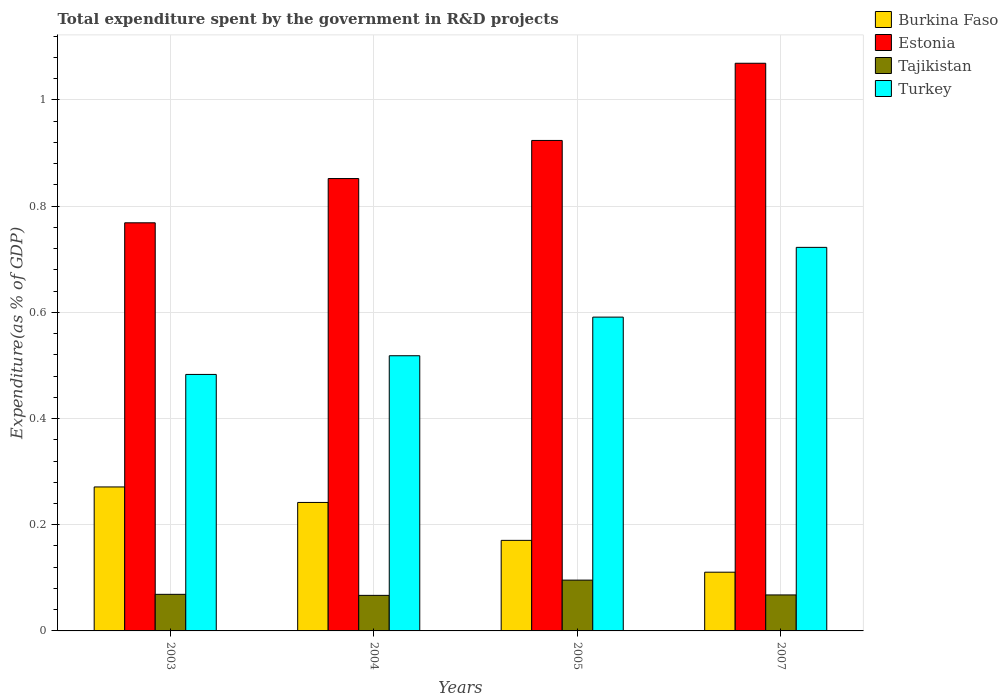How many different coloured bars are there?
Your answer should be very brief. 4. How many groups of bars are there?
Keep it short and to the point. 4. Are the number of bars per tick equal to the number of legend labels?
Provide a succinct answer. Yes. Are the number of bars on each tick of the X-axis equal?
Provide a succinct answer. Yes. How many bars are there on the 2nd tick from the right?
Offer a very short reply. 4. What is the total expenditure spent by the government in R&D projects in Tajikistan in 2003?
Give a very brief answer. 0.07. Across all years, what is the maximum total expenditure spent by the government in R&D projects in Turkey?
Your response must be concise. 0.72. Across all years, what is the minimum total expenditure spent by the government in R&D projects in Estonia?
Offer a terse response. 0.77. In which year was the total expenditure spent by the government in R&D projects in Tajikistan maximum?
Provide a succinct answer. 2005. What is the total total expenditure spent by the government in R&D projects in Estonia in the graph?
Keep it short and to the point. 3.61. What is the difference between the total expenditure spent by the government in R&D projects in Tajikistan in 2005 and that in 2007?
Provide a succinct answer. 0.03. What is the difference between the total expenditure spent by the government in R&D projects in Turkey in 2007 and the total expenditure spent by the government in R&D projects in Burkina Faso in 2004?
Provide a succinct answer. 0.48. What is the average total expenditure spent by the government in R&D projects in Tajikistan per year?
Give a very brief answer. 0.07. In the year 2005, what is the difference between the total expenditure spent by the government in R&D projects in Burkina Faso and total expenditure spent by the government in R&D projects in Estonia?
Provide a short and direct response. -0.75. What is the ratio of the total expenditure spent by the government in R&D projects in Tajikistan in 2005 to that in 2007?
Your answer should be very brief. 1.41. Is the total expenditure spent by the government in R&D projects in Turkey in 2003 less than that in 2007?
Make the answer very short. Yes. Is the difference between the total expenditure spent by the government in R&D projects in Burkina Faso in 2004 and 2005 greater than the difference between the total expenditure spent by the government in R&D projects in Estonia in 2004 and 2005?
Keep it short and to the point. Yes. What is the difference between the highest and the second highest total expenditure spent by the government in R&D projects in Estonia?
Your answer should be very brief. 0.15. What is the difference between the highest and the lowest total expenditure spent by the government in R&D projects in Estonia?
Your answer should be compact. 0.3. In how many years, is the total expenditure spent by the government in R&D projects in Tajikistan greater than the average total expenditure spent by the government in R&D projects in Tajikistan taken over all years?
Provide a short and direct response. 1. Is the sum of the total expenditure spent by the government in R&D projects in Burkina Faso in 2003 and 2007 greater than the maximum total expenditure spent by the government in R&D projects in Turkey across all years?
Your response must be concise. No. What does the 1st bar from the left in 2004 represents?
Give a very brief answer. Burkina Faso. What does the 4th bar from the right in 2004 represents?
Provide a short and direct response. Burkina Faso. Is it the case that in every year, the sum of the total expenditure spent by the government in R&D projects in Tajikistan and total expenditure spent by the government in R&D projects in Turkey is greater than the total expenditure spent by the government in R&D projects in Estonia?
Your answer should be compact. No. Are all the bars in the graph horizontal?
Provide a succinct answer. No. How many years are there in the graph?
Provide a succinct answer. 4. Does the graph contain any zero values?
Keep it short and to the point. No. What is the title of the graph?
Your answer should be very brief. Total expenditure spent by the government in R&D projects. Does "El Salvador" appear as one of the legend labels in the graph?
Offer a very short reply. No. What is the label or title of the X-axis?
Give a very brief answer. Years. What is the label or title of the Y-axis?
Provide a short and direct response. Expenditure(as % of GDP). What is the Expenditure(as % of GDP) of Burkina Faso in 2003?
Provide a short and direct response. 0.27. What is the Expenditure(as % of GDP) of Estonia in 2003?
Ensure brevity in your answer.  0.77. What is the Expenditure(as % of GDP) of Tajikistan in 2003?
Provide a short and direct response. 0.07. What is the Expenditure(as % of GDP) of Turkey in 2003?
Give a very brief answer. 0.48. What is the Expenditure(as % of GDP) of Burkina Faso in 2004?
Your answer should be very brief. 0.24. What is the Expenditure(as % of GDP) of Estonia in 2004?
Ensure brevity in your answer.  0.85. What is the Expenditure(as % of GDP) in Tajikistan in 2004?
Keep it short and to the point. 0.07. What is the Expenditure(as % of GDP) of Turkey in 2004?
Your response must be concise. 0.52. What is the Expenditure(as % of GDP) in Burkina Faso in 2005?
Provide a short and direct response. 0.17. What is the Expenditure(as % of GDP) of Estonia in 2005?
Make the answer very short. 0.92. What is the Expenditure(as % of GDP) in Tajikistan in 2005?
Your answer should be very brief. 0.1. What is the Expenditure(as % of GDP) of Turkey in 2005?
Your answer should be compact. 0.59. What is the Expenditure(as % of GDP) of Burkina Faso in 2007?
Your answer should be compact. 0.11. What is the Expenditure(as % of GDP) of Estonia in 2007?
Offer a terse response. 1.07. What is the Expenditure(as % of GDP) in Tajikistan in 2007?
Your answer should be very brief. 0.07. What is the Expenditure(as % of GDP) of Turkey in 2007?
Keep it short and to the point. 0.72. Across all years, what is the maximum Expenditure(as % of GDP) of Burkina Faso?
Offer a terse response. 0.27. Across all years, what is the maximum Expenditure(as % of GDP) in Estonia?
Ensure brevity in your answer.  1.07. Across all years, what is the maximum Expenditure(as % of GDP) in Tajikistan?
Offer a terse response. 0.1. Across all years, what is the maximum Expenditure(as % of GDP) in Turkey?
Offer a very short reply. 0.72. Across all years, what is the minimum Expenditure(as % of GDP) of Burkina Faso?
Ensure brevity in your answer.  0.11. Across all years, what is the minimum Expenditure(as % of GDP) in Estonia?
Your answer should be compact. 0.77. Across all years, what is the minimum Expenditure(as % of GDP) in Tajikistan?
Provide a succinct answer. 0.07. Across all years, what is the minimum Expenditure(as % of GDP) of Turkey?
Offer a very short reply. 0.48. What is the total Expenditure(as % of GDP) in Burkina Faso in the graph?
Keep it short and to the point. 0.79. What is the total Expenditure(as % of GDP) in Estonia in the graph?
Keep it short and to the point. 3.61. What is the total Expenditure(as % of GDP) in Tajikistan in the graph?
Ensure brevity in your answer.  0.3. What is the total Expenditure(as % of GDP) in Turkey in the graph?
Your response must be concise. 2.31. What is the difference between the Expenditure(as % of GDP) in Burkina Faso in 2003 and that in 2004?
Make the answer very short. 0.03. What is the difference between the Expenditure(as % of GDP) in Estonia in 2003 and that in 2004?
Keep it short and to the point. -0.08. What is the difference between the Expenditure(as % of GDP) of Tajikistan in 2003 and that in 2004?
Offer a terse response. 0. What is the difference between the Expenditure(as % of GDP) in Turkey in 2003 and that in 2004?
Your response must be concise. -0.04. What is the difference between the Expenditure(as % of GDP) in Burkina Faso in 2003 and that in 2005?
Your response must be concise. 0.1. What is the difference between the Expenditure(as % of GDP) of Estonia in 2003 and that in 2005?
Provide a succinct answer. -0.16. What is the difference between the Expenditure(as % of GDP) of Tajikistan in 2003 and that in 2005?
Provide a succinct answer. -0.03. What is the difference between the Expenditure(as % of GDP) of Turkey in 2003 and that in 2005?
Make the answer very short. -0.11. What is the difference between the Expenditure(as % of GDP) in Burkina Faso in 2003 and that in 2007?
Your answer should be compact. 0.16. What is the difference between the Expenditure(as % of GDP) in Estonia in 2003 and that in 2007?
Your response must be concise. -0.3. What is the difference between the Expenditure(as % of GDP) of Tajikistan in 2003 and that in 2007?
Offer a terse response. 0. What is the difference between the Expenditure(as % of GDP) in Turkey in 2003 and that in 2007?
Your answer should be compact. -0.24. What is the difference between the Expenditure(as % of GDP) of Burkina Faso in 2004 and that in 2005?
Offer a terse response. 0.07. What is the difference between the Expenditure(as % of GDP) in Estonia in 2004 and that in 2005?
Make the answer very short. -0.07. What is the difference between the Expenditure(as % of GDP) in Tajikistan in 2004 and that in 2005?
Offer a very short reply. -0.03. What is the difference between the Expenditure(as % of GDP) of Turkey in 2004 and that in 2005?
Make the answer very short. -0.07. What is the difference between the Expenditure(as % of GDP) in Burkina Faso in 2004 and that in 2007?
Keep it short and to the point. 0.13. What is the difference between the Expenditure(as % of GDP) in Estonia in 2004 and that in 2007?
Provide a succinct answer. -0.22. What is the difference between the Expenditure(as % of GDP) of Tajikistan in 2004 and that in 2007?
Make the answer very short. -0. What is the difference between the Expenditure(as % of GDP) in Turkey in 2004 and that in 2007?
Ensure brevity in your answer.  -0.2. What is the difference between the Expenditure(as % of GDP) in Estonia in 2005 and that in 2007?
Offer a very short reply. -0.15. What is the difference between the Expenditure(as % of GDP) of Tajikistan in 2005 and that in 2007?
Ensure brevity in your answer.  0.03. What is the difference between the Expenditure(as % of GDP) of Turkey in 2005 and that in 2007?
Make the answer very short. -0.13. What is the difference between the Expenditure(as % of GDP) of Burkina Faso in 2003 and the Expenditure(as % of GDP) of Estonia in 2004?
Your answer should be very brief. -0.58. What is the difference between the Expenditure(as % of GDP) of Burkina Faso in 2003 and the Expenditure(as % of GDP) of Tajikistan in 2004?
Offer a very short reply. 0.2. What is the difference between the Expenditure(as % of GDP) of Burkina Faso in 2003 and the Expenditure(as % of GDP) of Turkey in 2004?
Offer a very short reply. -0.25. What is the difference between the Expenditure(as % of GDP) of Estonia in 2003 and the Expenditure(as % of GDP) of Tajikistan in 2004?
Ensure brevity in your answer.  0.7. What is the difference between the Expenditure(as % of GDP) in Estonia in 2003 and the Expenditure(as % of GDP) in Turkey in 2004?
Provide a short and direct response. 0.25. What is the difference between the Expenditure(as % of GDP) in Tajikistan in 2003 and the Expenditure(as % of GDP) in Turkey in 2004?
Offer a terse response. -0.45. What is the difference between the Expenditure(as % of GDP) of Burkina Faso in 2003 and the Expenditure(as % of GDP) of Estonia in 2005?
Give a very brief answer. -0.65. What is the difference between the Expenditure(as % of GDP) in Burkina Faso in 2003 and the Expenditure(as % of GDP) in Tajikistan in 2005?
Provide a short and direct response. 0.18. What is the difference between the Expenditure(as % of GDP) in Burkina Faso in 2003 and the Expenditure(as % of GDP) in Turkey in 2005?
Make the answer very short. -0.32. What is the difference between the Expenditure(as % of GDP) in Estonia in 2003 and the Expenditure(as % of GDP) in Tajikistan in 2005?
Make the answer very short. 0.67. What is the difference between the Expenditure(as % of GDP) in Estonia in 2003 and the Expenditure(as % of GDP) in Turkey in 2005?
Your answer should be very brief. 0.18. What is the difference between the Expenditure(as % of GDP) in Tajikistan in 2003 and the Expenditure(as % of GDP) in Turkey in 2005?
Your answer should be very brief. -0.52. What is the difference between the Expenditure(as % of GDP) of Burkina Faso in 2003 and the Expenditure(as % of GDP) of Estonia in 2007?
Ensure brevity in your answer.  -0.8. What is the difference between the Expenditure(as % of GDP) in Burkina Faso in 2003 and the Expenditure(as % of GDP) in Tajikistan in 2007?
Keep it short and to the point. 0.2. What is the difference between the Expenditure(as % of GDP) of Burkina Faso in 2003 and the Expenditure(as % of GDP) of Turkey in 2007?
Make the answer very short. -0.45. What is the difference between the Expenditure(as % of GDP) of Estonia in 2003 and the Expenditure(as % of GDP) of Tajikistan in 2007?
Your response must be concise. 0.7. What is the difference between the Expenditure(as % of GDP) of Estonia in 2003 and the Expenditure(as % of GDP) of Turkey in 2007?
Your response must be concise. 0.05. What is the difference between the Expenditure(as % of GDP) of Tajikistan in 2003 and the Expenditure(as % of GDP) of Turkey in 2007?
Offer a very short reply. -0.65. What is the difference between the Expenditure(as % of GDP) in Burkina Faso in 2004 and the Expenditure(as % of GDP) in Estonia in 2005?
Offer a very short reply. -0.68. What is the difference between the Expenditure(as % of GDP) of Burkina Faso in 2004 and the Expenditure(as % of GDP) of Tajikistan in 2005?
Provide a short and direct response. 0.15. What is the difference between the Expenditure(as % of GDP) of Burkina Faso in 2004 and the Expenditure(as % of GDP) of Turkey in 2005?
Offer a very short reply. -0.35. What is the difference between the Expenditure(as % of GDP) in Estonia in 2004 and the Expenditure(as % of GDP) in Tajikistan in 2005?
Provide a short and direct response. 0.76. What is the difference between the Expenditure(as % of GDP) of Estonia in 2004 and the Expenditure(as % of GDP) of Turkey in 2005?
Offer a very short reply. 0.26. What is the difference between the Expenditure(as % of GDP) in Tajikistan in 2004 and the Expenditure(as % of GDP) in Turkey in 2005?
Offer a very short reply. -0.52. What is the difference between the Expenditure(as % of GDP) in Burkina Faso in 2004 and the Expenditure(as % of GDP) in Estonia in 2007?
Keep it short and to the point. -0.83. What is the difference between the Expenditure(as % of GDP) in Burkina Faso in 2004 and the Expenditure(as % of GDP) in Tajikistan in 2007?
Your answer should be compact. 0.17. What is the difference between the Expenditure(as % of GDP) in Burkina Faso in 2004 and the Expenditure(as % of GDP) in Turkey in 2007?
Ensure brevity in your answer.  -0.48. What is the difference between the Expenditure(as % of GDP) in Estonia in 2004 and the Expenditure(as % of GDP) in Tajikistan in 2007?
Your answer should be compact. 0.78. What is the difference between the Expenditure(as % of GDP) in Estonia in 2004 and the Expenditure(as % of GDP) in Turkey in 2007?
Give a very brief answer. 0.13. What is the difference between the Expenditure(as % of GDP) of Tajikistan in 2004 and the Expenditure(as % of GDP) of Turkey in 2007?
Your answer should be compact. -0.66. What is the difference between the Expenditure(as % of GDP) in Burkina Faso in 2005 and the Expenditure(as % of GDP) in Estonia in 2007?
Your response must be concise. -0.9. What is the difference between the Expenditure(as % of GDP) of Burkina Faso in 2005 and the Expenditure(as % of GDP) of Tajikistan in 2007?
Offer a terse response. 0.1. What is the difference between the Expenditure(as % of GDP) in Burkina Faso in 2005 and the Expenditure(as % of GDP) in Turkey in 2007?
Provide a short and direct response. -0.55. What is the difference between the Expenditure(as % of GDP) of Estonia in 2005 and the Expenditure(as % of GDP) of Tajikistan in 2007?
Your answer should be very brief. 0.86. What is the difference between the Expenditure(as % of GDP) of Estonia in 2005 and the Expenditure(as % of GDP) of Turkey in 2007?
Provide a short and direct response. 0.2. What is the difference between the Expenditure(as % of GDP) in Tajikistan in 2005 and the Expenditure(as % of GDP) in Turkey in 2007?
Your answer should be very brief. -0.63. What is the average Expenditure(as % of GDP) of Burkina Faso per year?
Keep it short and to the point. 0.2. What is the average Expenditure(as % of GDP) in Estonia per year?
Keep it short and to the point. 0.9. What is the average Expenditure(as % of GDP) in Tajikistan per year?
Keep it short and to the point. 0.07. What is the average Expenditure(as % of GDP) of Turkey per year?
Provide a succinct answer. 0.58. In the year 2003, what is the difference between the Expenditure(as % of GDP) in Burkina Faso and Expenditure(as % of GDP) in Estonia?
Your answer should be very brief. -0.5. In the year 2003, what is the difference between the Expenditure(as % of GDP) in Burkina Faso and Expenditure(as % of GDP) in Tajikistan?
Your response must be concise. 0.2. In the year 2003, what is the difference between the Expenditure(as % of GDP) of Burkina Faso and Expenditure(as % of GDP) of Turkey?
Your answer should be compact. -0.21. In the year 2003, what is the difference between the Expenditure(as % of GDP) of Estonia and Expenditure(as % of GDP) of Tajikistan?
Offer a terse response. 0.7. In the year 2003, what is the difference between the Expenditure(as % of GDP) of Estonia and Expenditure(as % of GDP) of Turkey?
Give a very brief answer. 0.29. In the year 2003, what is the difference between the Expenditure(as % of GDP) of Tajikistan and Expenditure(as % of GDP) of Turkey?
Provide a short and direct response. -0.41. In the year 2004, what is the difference between the Expenditure(as % of GDP) of Burkina Faso and Expenditure(as % of GDP) of Estonia?
Provide a short and direct response. -0.61. In the year 2004, what is the difference between the Expenditure(as % of GDP) in Burkina Faso and Expenditure(as % of GDP) in Tajikistan?
Your response must be concise. 0.17. In the year 2004, what is the difference between the Expenditure(as % of GDP) of Burkina Faso and Expenditure(as % of GDP) of Turkey?
Give a very brief answer. -0.28. In the year 2004, what is the difference between the Expenditure(as % of GDP) of Estonia and Expenditure(as % of GDP) of Tajikistan?
Keep it short and to the point. 0.79. In the year 2004, what is the difference between the Expenditure(as % of GDP) in Estonia and Expenditure(as % of GDP) in Turkey?
Give a very brief answer. 0.33. In the year 2004, what is the difference between the Expenditure(as % of GDP) in Tajikistan and Expenditure(as % of GDP) in Turkey?
Offer a terse response. -0.45. In the year 2005, what is the difference between the Expenditure(as % of GDP) in Burkina Faso and Expenditure(as % of GDP) in Estonia?
Your answer should be compact. -0.75. In the year 2005, what is the difference between the Expenditure(as % of GDP) of Burkina Faso and Expenditure(as % of GDP) of Tajikistan?
Offer a very short reply. 0.07. In the year 2005, what is the difference between the Expenditure(as % of GDP) in Burkina Faso and Expenditure(as % of GDP) in Turkey?
Provide a succinct answer. -0.42. In the year 2005, what is the difference between the Expenditure(as % of GDP) in Estonia and Expenditure(as % of GDP) in Tajikistan?
Your answer should be very brief. 0.83. In the year 2005, what is the difference between the Expenditure(as % of GDP) in Estonia and Expenditure(as % of GDP) in Turkey?
Provide a short and direct response. 0.33. In the year 2005, what is the difference between the Expenditure(as % of GDP) of Tajikistan and Expenditure(as % of GDP) of Turkey?
Your answer should be very brief. -0.5. In the year 2007, what is the difference between the Expenditure(as % of GDP) in Burkina Faso and Expenditure(as % of GDP) in Estonia?
Make the answer very short. -0.96. In the year 2007, what is the difference between the Expenditure(as % of GDP) of Burkina Faso and Expenditure(as % of GDP) of Tajikistan?
Offer a terse response. 0.04. In the year 2007, what is the difference between the Expenditure(as % of GDP) in Burkina Faso and Expenditure(as % of GDP) in Turkey?
Keep it short and to the point. -0.61. In the year 2007, what is the difference between the Expenditure(as % of GDP) in Estonia and Expenditure(as % of GDP) in Tajikistan?
Offer a very short reply. 1. In the year 2007, what is the difference between the Expenditure(as % of GDP) of Estonia and Expenditure(as % of GDP) of Turkey?
Provide a short and direct response. 0.35. In the year 2007, what is the difference between the Expenditure(as % of GDP) of Tajikistan and Expenditure(as % of GDP) of Turkey?
Your answer should be very brief. -0.65. What is the ratio of the Expenditure(as % of GDP) in Burkina Faso in 2003 to that in 2004?
Provide a short and direct response. 1.12. What is the ratio of the Expenditure(as % of GDP) of Estonia in 2003 to that in 2004?
Make the answer very short. 0.9. What is the ratio of the Expenditure(as % of GDP) in Tajikistan in 2003 to that in 2004?
Ensure brevity in your answer.  1.03. What is the ratio of the Expenditure(as % of GDP) in Turkey in 2003 to that in 2004?
Your answer should be compact. 0.93. What is the ratio of the Expenditure(as % of GDP) in Burkina Faso in 2003 to that in 2005?
Ensure brevity in your answer.  1.59. What is the ratio of the Expenditure(as % of GDP) in Estonia in 2003 to that in 2005?
Offer a very short reply. 0.83. What is the ratio of the Expenditure(as % of GDP) in Tajikistan in 2003 to that in 2005?
Offer a very short reply. 0.72. What is the ratio of the Expenditure(as % of GDP) of Turkey in 2003 to that in 2005?
Your answer should be compact. 0.82. What is the ratio of the Expenditure(as % of GDP) in Burkina Faso in 2003 to that in 2007?
Offer a very short reply. 2.45. What is the ratio of the Expenditure(as % of GDP) of Estonia in 2003 to that in 2007?
Offer a very short reply. 0.72. What is the ratio of the Expenditure(as % of GDP) in Tajikistan in 2003 to that in 2007?
Ensure brevity in your answer.  1.02. What is the ratio of the Expenditure(as % of GDP) of Turkey in 2003 to that in 2007?
Provide a short and direct response. 0.67. What is the ratio of the Expenditure(as % of GDP) of Burkina Faso in 2004 to that in 2005?
Offer a very short reply. 1.42. What is the ratio of the Expenditure(as % of GDP) of Estonia in 2004 to that in 2005?
Offer a terse response. 0.92. What is the ratio of the Expenditure(as % of GDP) in Tajikistan in 2004 to that in 2005?
Provide a succinct answer. 0.7. What is the ratio of the Expenditure(as % of GDP) of Turkey in 2004 to that in 2005?
Your answer should be compact. 0.88. What is the ratio of the Expenditure(as % of GDP) in Burkina Faso in 2004 to that in 2007?
Your response must be concise. 2.19. What is the ratio of the Expenditure(as % of GDP) of Estonia in 2004 to that in 2007?
Provide a short and direct response. 0.8. What is the ratio of the Expenditure(as % of GDP) of Tajikistan in 2004 to that in 2007?
Offer a terse response. 0.99. What is the ratio of the Expenditure(as % of GDP) of Turkey in 2004 to that in 2007?
Offer a very short reply. 0.72. What is the ratio of the Expenditure(as % of GDP) in Burkina Faso in 2005 to that in 2007?
Your answer should be compact. 1.54. What is the ratio of the Expenditure(as % of GDP) in Estonia in 2005 to that in 2007?
Your answer should be very brief. 0.86. What is the ratio of the Expenditure(as % of GDP) in Tajikistan in 2005 to that in 2007?
Offer a very short reply. 1.41. What is the ratio of the Expenditure(as % of GDP) of Turkey in 2005 to that in 2007?
Your response must be concise. 0.82. What is the difference between the highest and the second highest Expenditure(as % of GDP) in Burkina Faso?
Provide a succinct answer. 0.03. What is the difference between the highest and the second highest Expenditure(as % of GDP) of Estonia?
Give a very brief answer. 0.15. What is the difference between the highest and the second highest Expenditure(as % of GDP) of Tajikistan?
Your response must be concise. 0.03. What is the difference between the highest and the second highest Expenditure(as % of GDP) in Turkey?
Your response must be concise. 0.13. What is the difference between the highest and the lowest Expenditure(as % of GDP) of Burkina Faso?
Your response must be concise. 0.16. What is the difference between the highest and the lowest Expenditure(as % of GDP) in Estonia?
Your answer should be very brief. 0.3. What is the difference between the highest and the lowest Expenditure(as % of GDP) of Tajikistan?
Provide a succinct answer. 0.03. What is the difference between the highest and the lowest Expenditure(as % of GDP) in Turkey?
Provide a short and direct response. 0.24. 